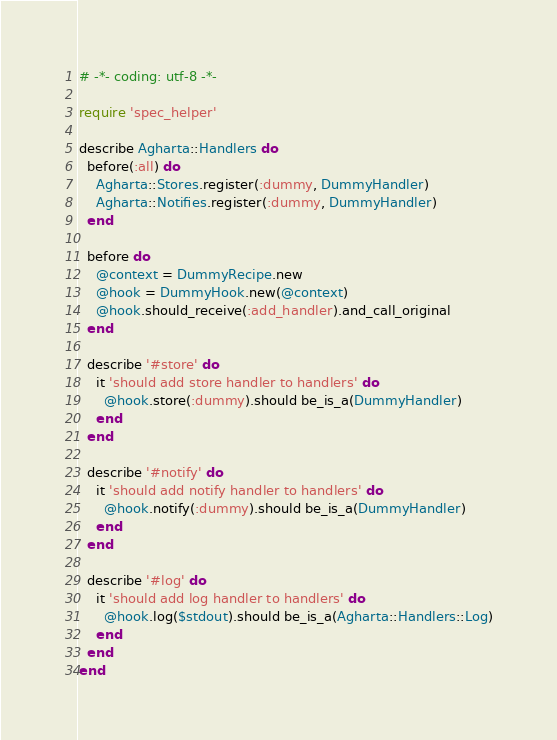<code> <loc_0><loc_0><loc_500><loc_500><_Ruby_># -*- coding: utf-8 -*-

require 'spec_helper'

describe Agharta::Handlers do
  before(:all) do
    Agharta::Stores.register(:dummy, DummyHandler)
    Agharta::Notifies.register(:dummy, DummyHandler)
  end

  before do
    @context = DummyRecipe.new
    @hook = DummyHook.new(@context)
    @hook.should_receive(:add_handler).and_call_original
  end

  describe '#store' do
    it 'should add store handler to handlers' do
      @hook.store(:dummy).should be_is_a(DummyHandler)
    end
  end

  describe '#notify' do
    it 'should add notify handler to handlers' do
      @hook.notify(:dummy).should be_is_a(DummyHandler)
    end
  end

  describe '#log' do
    it 'should add log handler to handlers' do
      @hook.log($stdout).should be_is_a(Agharta::Handlers::Log)
    end
  end
end
</code> 